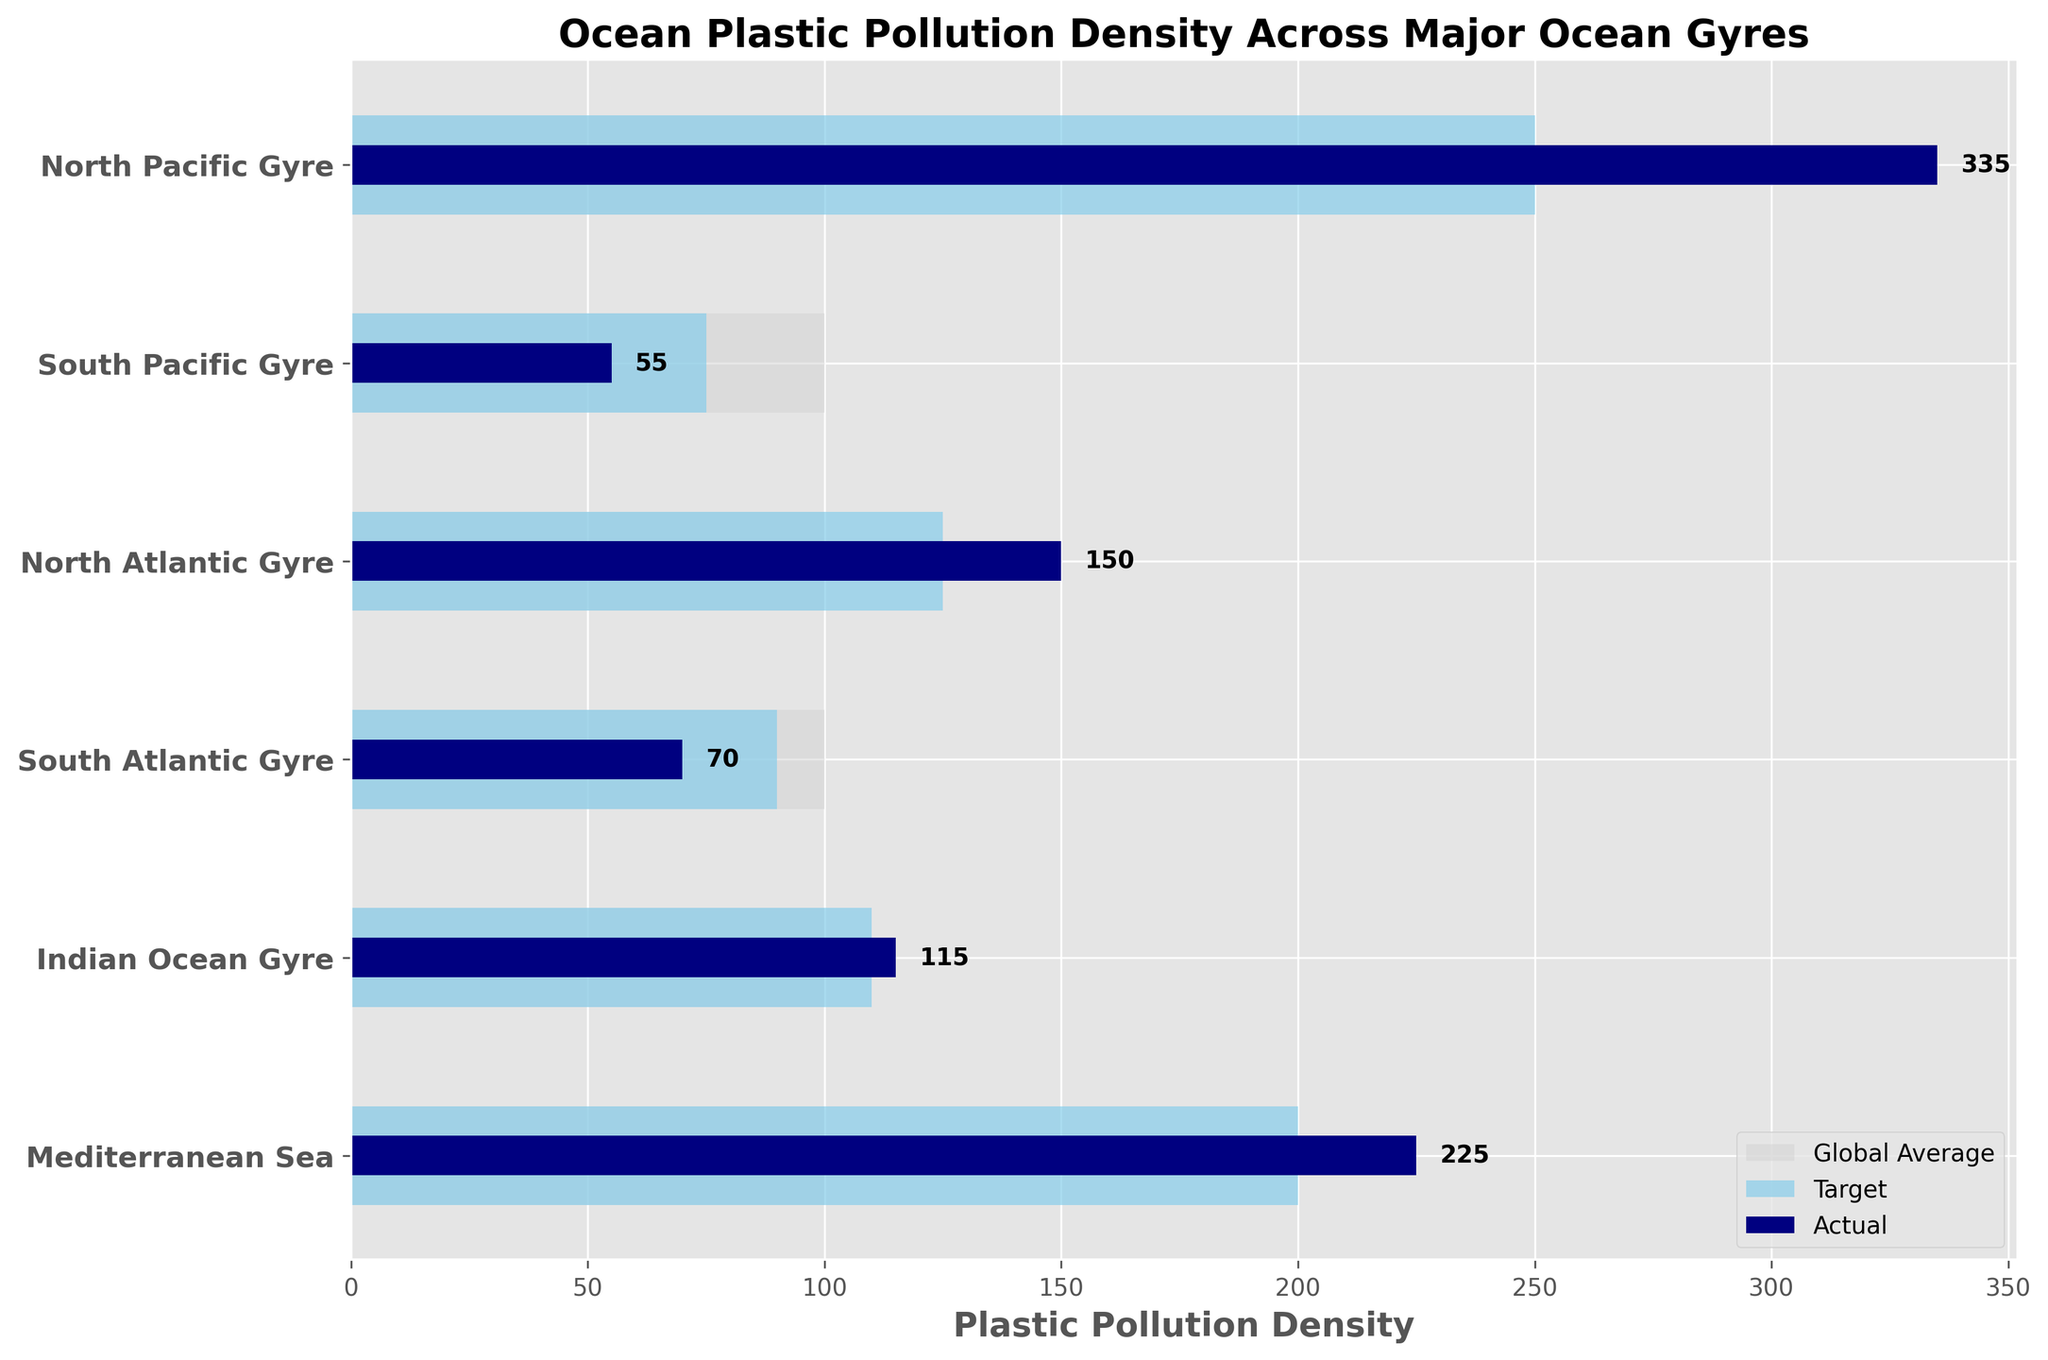What is the title of the figure? The title of the figure is displayed prominently at the top of the chart. It provides a summary of what the chart is about. In this case, the title is "Ocean Plastic Pollution Density Across Major Ocean Gyres".
Answer: Ocean Plastic Pollution Density Across Major Ocean Gyres Which gyre has the highest actual plastic pollution density? By looking at the length of the navy bars for each gyre, we can compare their lengths to determine which one is the longest. The North Pacific Gyre has the highest actual plastic pollution density with a value of 335.
Answer: North Pacific Gyre How many major ocean gyres are included in the figure? The y-axis lists the names of the categories (major ocean gyres), and by counting these categories, we can determine the total number. There are six gyres listed.
Answer: 6 What is the target pollution density for the North Atlantic Gyre? The target pollution density is shown as the skyblue bar for each gyre. The value for the North Atlantic Gyre’s target is 125.
Answer: 125 Which gyre has an actual pollution density closest to its target? We need to compare the difference between the actual pollution density (navy bar) and the target pollution density (skyblue bar) for each gyre. For the Indian Ocean Gyre, the actual density is 115 and the target is 110, making it the closest with a difference of 5.
Answer: Indian Ocean Gyre Is the actual plastic pollution density in the Mediterranean Sea higher than the global average? We compare the length of the navy bar (actual) for the Mediterranean Sea to the length of the light grey bar (global average). The actual value for the Mediterranean Sea is 225, while the global average is 100. Therefore, the actual density is higher.
Answer: Yes Calculate the total actual plastic pollution density across all major ocean gyres. Sum the actual pollution densities for each gyre: North Pacific Gyre (335) + South Pacific Gyre (55) + North Atlantic Gyre (150) + South Atlantic Gyre (70) + Indian Ocean Gyre (115) + Mediterranean Sea (225). This yields a total of 335 + 55 + 150 + 70 + 115 + 225 = 950.
Answer: 950 Which gyre exceeds its target pollution density by the largest margin and by how much? We need to find the difference between the actual and target values for each gyre and identify the largest margin. North Pacific Gyre exceeds its target by 335 - 250 = 85, the largest margin among the gyres.
Answer: North Pacific Gyre by 85 Which gyre's actual pollution density is lower than the target density? By comparing the actual (navy bar) to target (skyblue bar) values, the South Pacific Gyre (55 vs. 75) and South Atlantic Gyre (70 vs. 90) both have actual densities lower than their target densities.
Answer: South Pacific Gyre, South Atlantic Gyre 